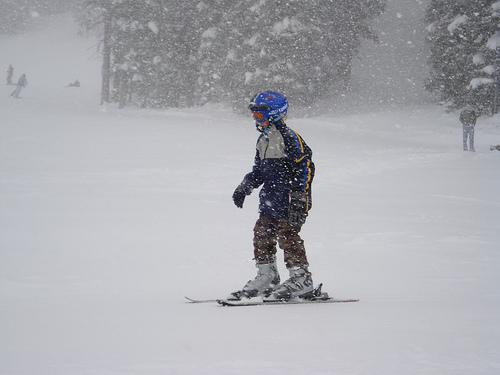Describe the surroundings of the main subject in the image. The main subject is skiing amidst dense trees covered in snow, with other skiers and a person standing on the side of the field in the background. Describe the overall atmosphere of the image. The image evokes a wintery atmosphere, with a young skier navigating a snowy landscape, surrounded by thick falling snow, dense trees, and other skiers in the background. Mention the key features of the skier's attire in the image. The skier is wearing a blue helmet and goggles, a winter coat with a yellow stripe on the sleeve, and a pair of brown pants. Write a sentence that captures the weather condition in the image. In the image, large snowflakes are falling against a gray background, creating a heavy snowfall scene. Mention the primary focus of the image and its background elements. The primary focus of the image is a kid skiing in heavy snowfall, with other skiers, a person standing on the side, and snow-covered trees as background elements. Give a concise description of the main subject's attire. The main subject is sporting a blue helmet, goggles, a winter coat with a yellow stripe, and brown pants. What is the main activity taking place in the image? The main activity in the image is a kid skiing in heavy snowfall, wearing protective gear and winter clothing. Provide a brief overview of the scene captured in the image. The image shows a kid skiing in heavy snowfall, wearing a blue helmet and goggles, a winter coat, and brown pants; other skiers and dense trees can be seen in the background. In your own words, describe what the person in the image is doing. The person in the image is skiing down a snow-covered slope, wearing a helmet, goggles, and winter clothing, while surrounded by trees and other skiers. Write a one-sentence summary of the image. The image captures a young skier wearing a blue helmet and goggles, gliding through a snowy landscape with other skiers and dense trees in the background. 